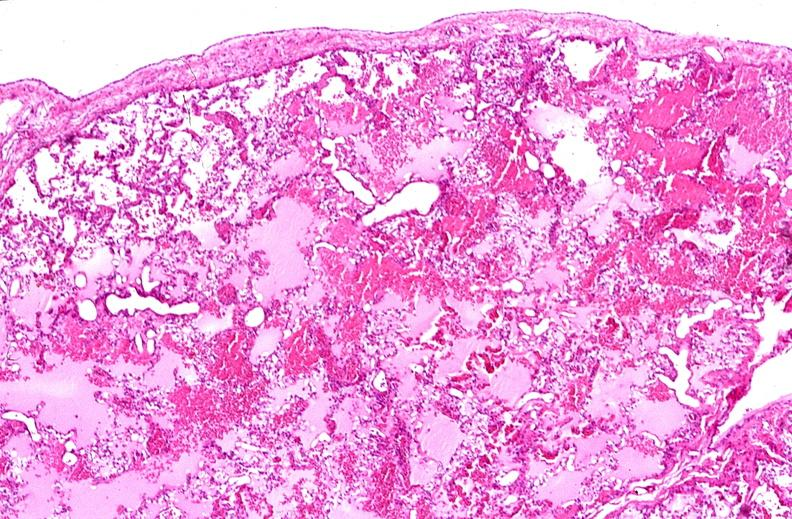what does this image show?
Answer the question using a single word or phrase. Lung 